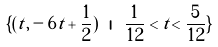Convert formula to latex. <formula><loc_0><loc_0><loc_500><loc_500>\{ ( t , - 6 t + \frac { 1 } { 2 } ) \ | \ \frac { 1 } { 1 2 } < t < \frac { 5 } { 1 2 } \}</formula> 